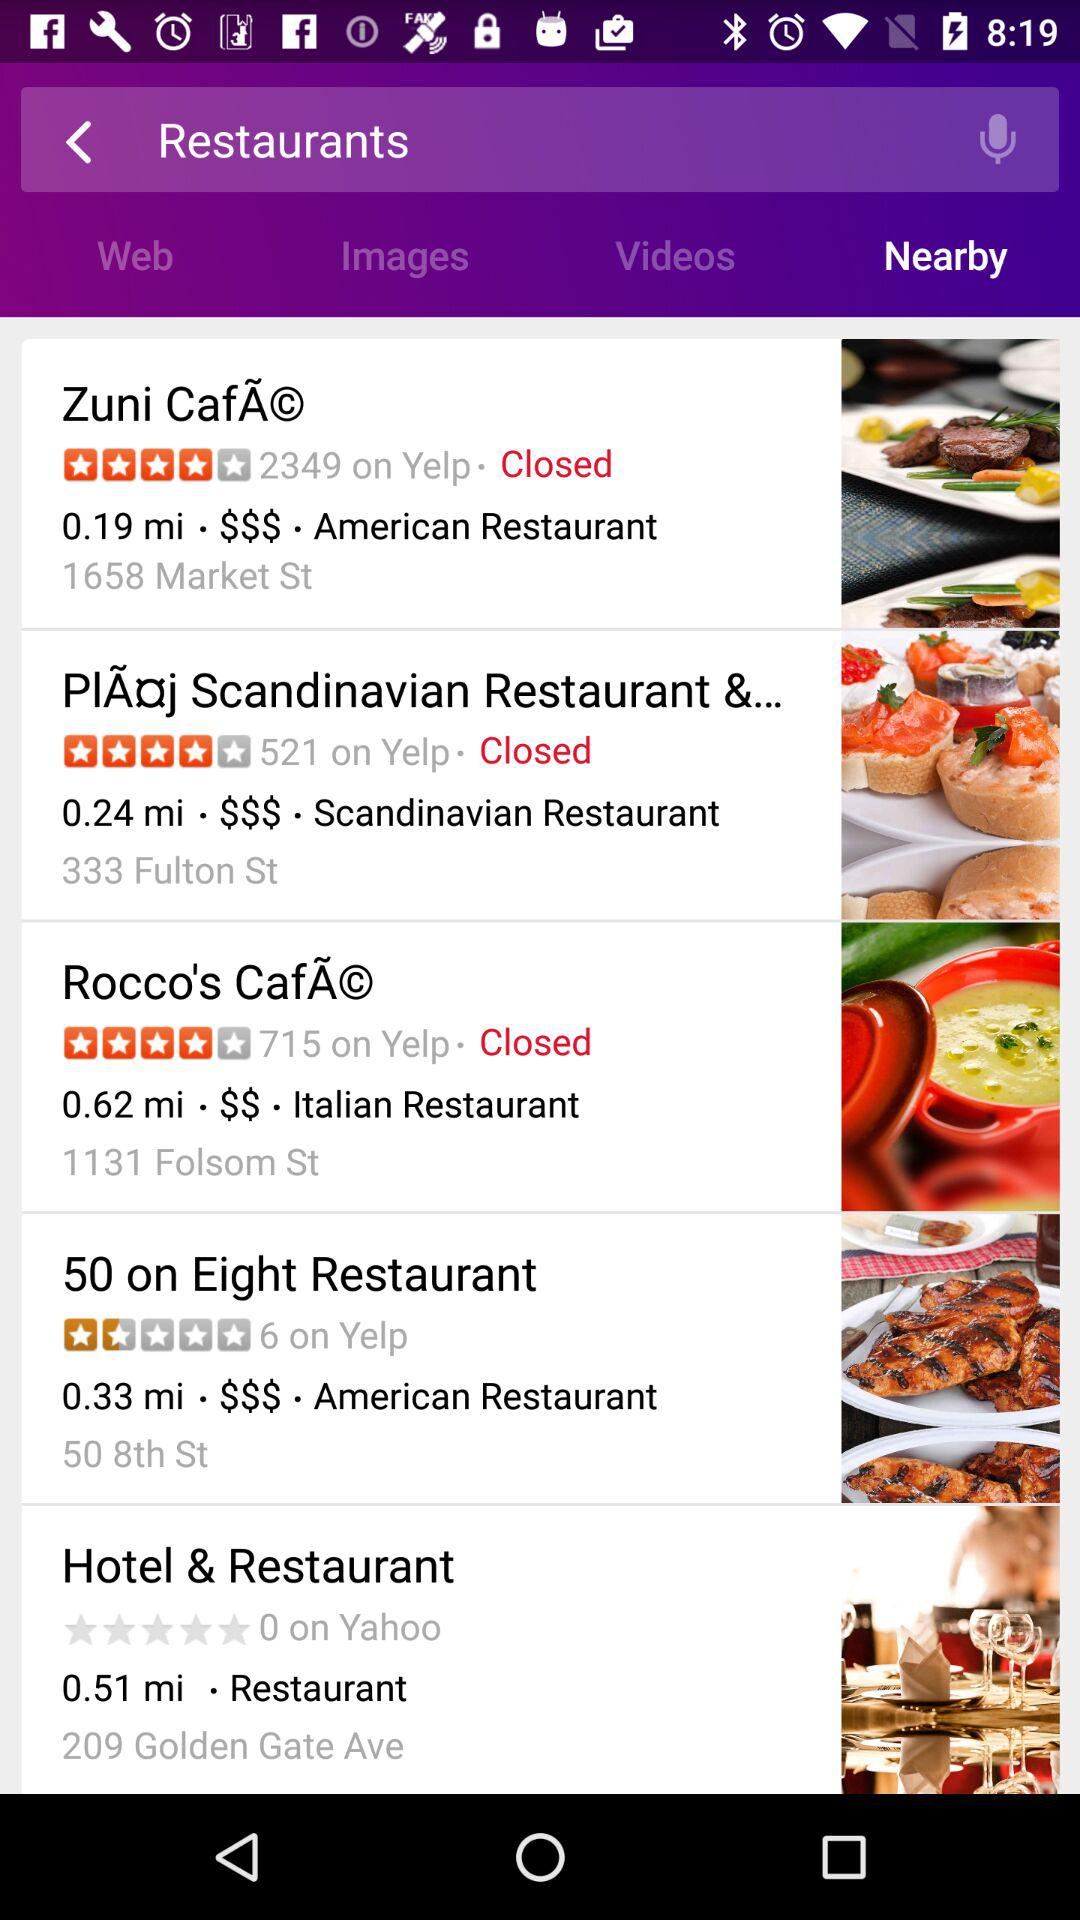Which tab is selected? The selected tab is "Nearby". 